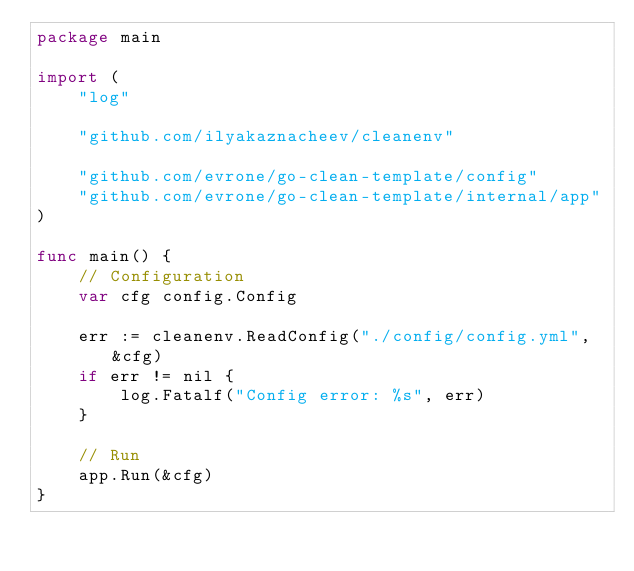<code> <loc_0><loc_0><loc_500><loc_500><_Go_>package main

import (
	"log"

	"github.com/ilyakaznacheev/cleanenv"

	"github.com/evrone/go-clean-template/config"
	"github.com/evrone/go-clean-template/internal/app"
)

func main() {
	// Configuration
	var cfg config.Config

	err := cleanenv.ReadConfig("./config/config.yml", &cfg)
	if err != nil {
		log.Fatalf("Config error: %s", err)
	}

	// Run
	app.Run(&cfg)
}
</code> 